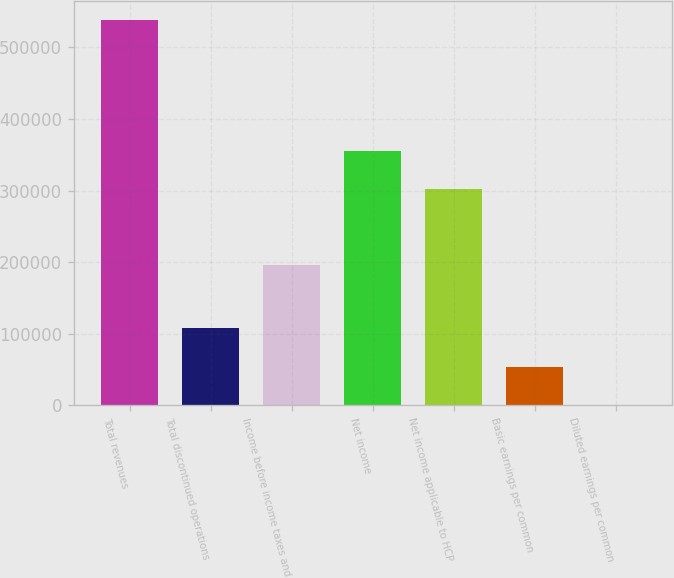Convert chart to OTSL. <chart><loc_0><loc_0><loc_500><loc_500><bar_chart><fcel>Total revenues<fcel>Total discontinued operations<fcel>Income before income taxes and<fcel>Net income<fcel>Net income applicable to HCP<fcel>Basic earnings per common<fcel>Diluted earnings per common<nl><fcel>538332<fcel>107667<fcel>196352<fcel>355550<fcel>301717<fcel>53833.8<fcel>0.64<nl></chart> 